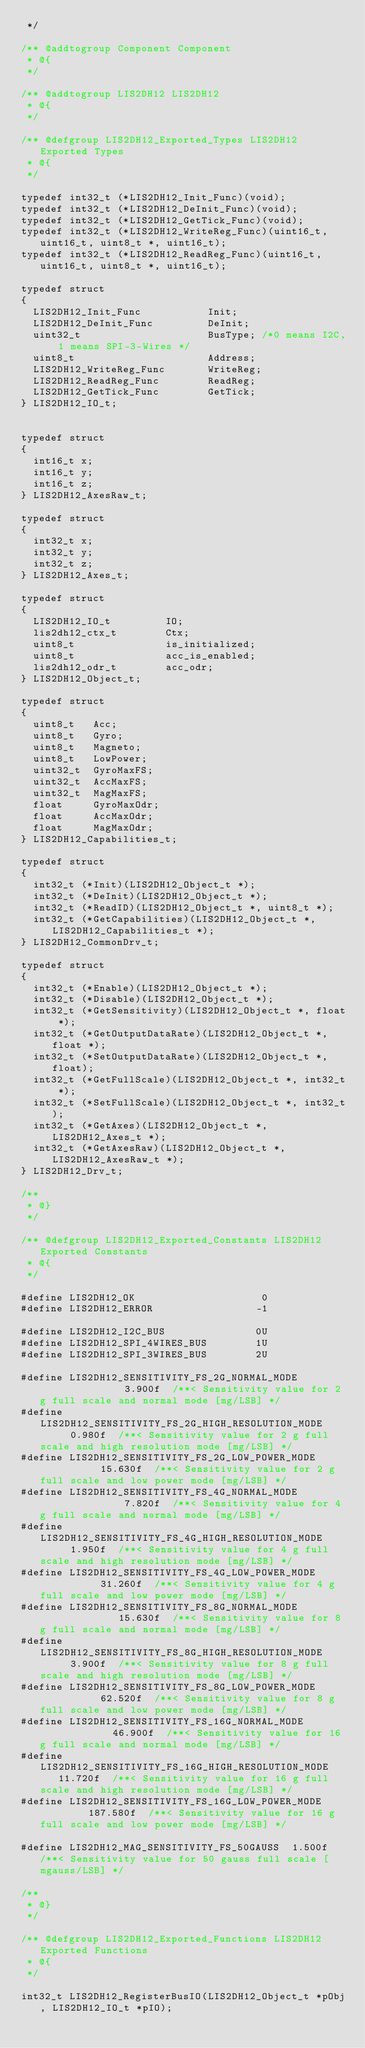Convert code to text. <code><loc_0><loc_0><loc_500><loc_500><_C_> */

/** @addtogroup Component Component
 * @{
 */

/** @addtogroup LIS2DH12 LIS2DH12
 * @{
 */

/** @defgroup LIS2DH12_Exported_Types LIS2DH12 Exported Types
 * @{
 */

typedef int32_t (*LIS2DH12_Init_Func)(void);
typedef int32_t (*LIS2DH12_DeInit_Func)(void);
typedef int32_t (*LIS2DH12_GetTick_Func)(void);
typedef int32_t (*LIS2DH12_WriteReg_Func)(uint16_t, uint16_t, uint8_t *, uint16_t);
typedef int32_t (*LIS2DH12_ReadReg_Func)(uint16_t, uint16_t, uint8_t *, uint16_t);

typedef struct
{
  LIS2DH12_Init_Func           Init;
  LIS2DH12_DeInit_Func         DeInit;
  uint32_t                     BusType; /*0 means I2C, 1 means SPI-3-Wires */
  uint8_t                      Address;
  LIS2DH12_WriteReg_Func       WriteReg;
  LIS2DH12_ReadReg_Func        ReadReg;
  LIS2DH12_GetTick_Func        GetTick;
} LIS2DH12_IO_t;


typedef struct
{
  int16_t x;
  int16_t y;
  int16_t z;
} LIS2DH12_AxesRaw_t;

typedef struct
{
  int32_t x;
  int32_t y;
  int32_t z;
} LIS2DH12_Axes_t;

typedef struct
{
  LIS2DH12_IO_t         IO;
  lis2dh12_ctx_t        Ctx;
  uint8_t               is_initialized;
  uint8_t               acc_is_enabled;
  lis2dh12_odr_t        acc_odr;
} LIS2DH12_Object_t;

typedef struct
{
  uint8_t   Acc;
  uint8_t   Gyro;
  uint8_t   Magneto;
  uint8_t   LowPower;
  uint32_t  GyroMaxFS;
  uint32_t  AccMaxFS;
  uint32_t  MagMaxFS;
  float     GyroMaxOdr;
  float     AccMaxOdr;
  float     MagMaxOdr;
} LIS2DH12_Capabilities_t;

typedef struct
{
  int32_t (*Init)(LIS2DH12_Object_t *);
  int32_t (*DeInit)(LIS2DH12_Object_t *);
  int32_t (*ReadID)(LIS2DH12_Object_t *, uint8_t *);
  int32_t (*GetCapabilities)(LIS2DH12_Object_t *, LIS2DH12_Capabilities_t *);
} LIS2DH12_CommonDrv_t;

typedef struct
{
  int32_t (*Enable)(LIS2DH12_Object_t *);
  int32_t (*Disable)(LIS2DH12_Object_t *);
  int32_t (*GetSensitivity)(LIS2DH12_Object_t *, float *);
  int32_t (*GetOutputDataRate)(LIS2DH12_Object_t *, float *);
  int32_t (*SetOutputDataRate)(LIS2DH12_Object_t *, float);
  int32_t (*GetFullScale)(LIS2DH12_Object_t *, int32_t *);
  int32_t (*SetFullScale)(LIS2DH12_Object_t *, int32_t);
  int32_t (*GetAxes)(LIS2DH12_Object_t *, LIS2DH12_Axes_t *);
  int32_t (*GetAxesRaw)(LIS2DH12_Object_t *, LIS2DH12_AxesRaw_t *);
} LIS2DH12_Drv_t;

/**
 * @}
 */

/** @defgroup LIS2DH12_Exported_Constants LIS2DH12 Exported Constants
 * @{
 */

#define LIS2DH12_OK                     0
#define LIS2DH12_ERROR                 -1

#define LIS2DH12_I2C_BUS               0U
#define LIS2DH12_SPI_4WIRES_BUS        1U
#define LIS2DH12_SPI_3WIRES_BUS        2U

#define LIS2DH12_SENSITIVITY_FS_2G_NORMAL_MODE               3.900f  /**< Sensitivity value for 2 g full scale and normal mode [mg/LSB] */
#define LIS2DH12_SENSITIVITY_FS_2G_HIGH_RESOLUTION_MODE      0.980f  /**< Sensitivity value for 2 g full scale and high resolution mode [mg/LSB] */
#define LIS2DH12_SENSITIVITY_FS_2G_LOW_POWER_MODE           15.630f  /**< Sensitivity value for 2 g full scale and low power mode [mg/LSB] */
#define LIS2DH12_SENSITIVITY_FS_4G_NORMAL_MODE               7.820f  /**< Sensitivity value for 4 g full scale and normal mode [mg/LSB] */
#define LIS2DH12_SENSITIVITY_FS_4G_HIGH_RESOLUTION_MODE      1.950f  /**< Sensitivity value for 4 g full scale and high resolution mode [mg/LSB] */
#define LIS2DH12_SENSITIVITY_FS_4G_LOW_POWER_MODE           31.260f  /**< Sensitivity value for 4 g full scale and low power mode [mg/LSB] */
#define LIS2DH12_SENSITIVITY_FS_8G_NORMAL_MODE              15.630f  /**< Sensitivity value for 8 g full scale and normal mode [mg/LSB] */
#define LIS2DH12_SENSITIVITY_FS_8G_HIGH_RESOLUTION_MODE      3.900f  /**< Sensitivity value for 8 g full scale and high resolution mode [mg/LSB] */
#define LIS2DH12_SENSITIVITY_FS_8G_LOW_POWER_MODE           62.520f  /**< Sensitivity value for 8 g full scale and low power mode [mg/LSB] */
#define LIS2DH12_SENSITIVITY_FS_16G_NORMAL_MODE             46.900f  /**< Sensitivity value for 16 g full scale and normal mode [mg/LSB] */
#define LIS2DH12_SENSITIVITY_FS_16G_HIGH_RESOLUTION_MODE    11.720f  /**< Sensitivity value for 16 g full scale and high resolution mode [mg/LSB] */
#define LIS2DH12_SENSITIVITY_FS_16G_LOW_POWER_MODE         187.580f  /**< Sensitivity value for 16 g full scale and low power mode [mg/LSB] */

#define LIS2DH12_MAG_SENSITIVITY_FS_50GAUSS  1.500f  /**< Sensitivity value for 50 gauss full scale [mgauss/LSB] */

/**
 * @}
 */

/** @defgroup LIS2DH12_Exported_Functions LIS2DH12 Exported Functions
 * @{
 */

int32_t LIS2DH12_RegisterBusIO(LIS2DH12_Object_t *pObj, LIS2DH12_IO_t *pIO);</code> 